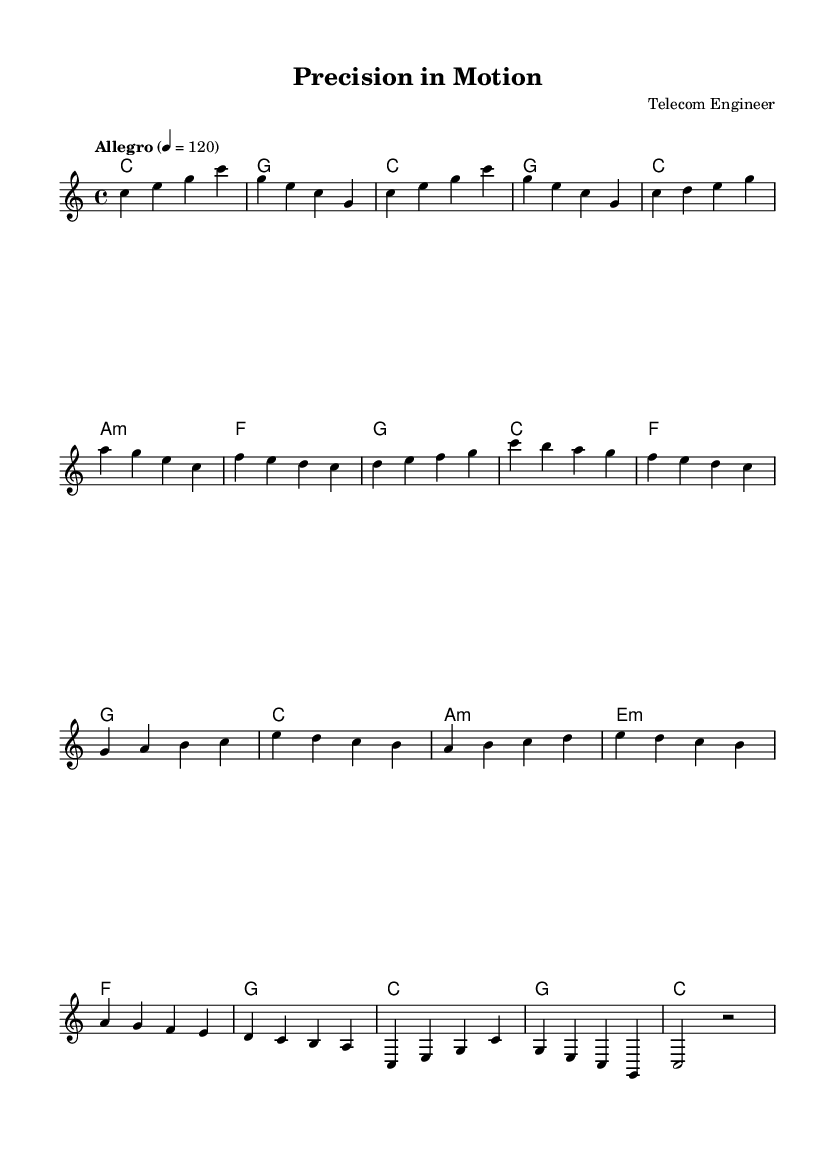What is the key signature of this music? The key signature is specified as C major, which is indicated by the absence of sharps or flats.
Answer: C major What is the time signature of this piece? The time signature is noted as 4/4, meaning there are four beats in each measure and a quarter note gets one beat.
Answer: 4/4 What tempo marking is given for this music? The tempo marking states "Allegro" with a metronome mark of 120, indicating a fast pace.
Answer: Allegro 4 = 120 How many measures does the introduction section have? The introduction section consists of four measures as indicated by the sequence of bar lines at the beginning.
Answer: 4 What is the chord progression in the chorus? The chords listed for the chorus include C, F, G, and C, which creates a common progression often used in many songs.
Answer: C, F, G, C In which section does the phrase "c d e g" appear? This phrase appears in the verse section, which can be confirmed by locating the melody writing before the chorus section.
Answer: Verse What is the final chord of the outro? The final chord of the outro is a C major chord, as shown before the final rest in the notation.
Answer: C 